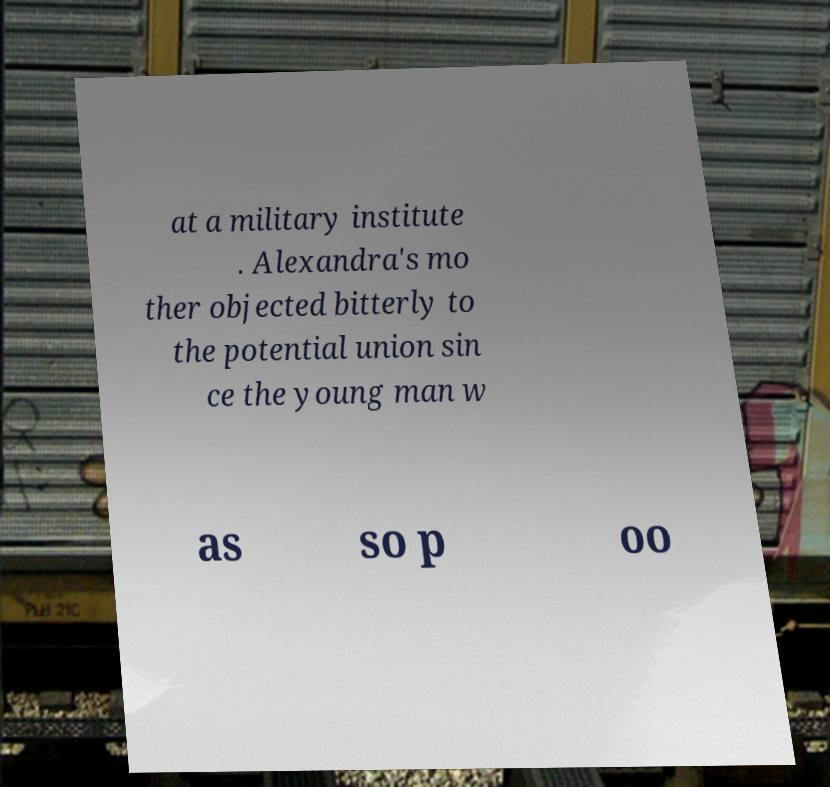Please identify and transcribe the text found in this image. at a military institute . Alexandra's mo ther objected bitterly to the potential union sin ce the young man w as so p oo 